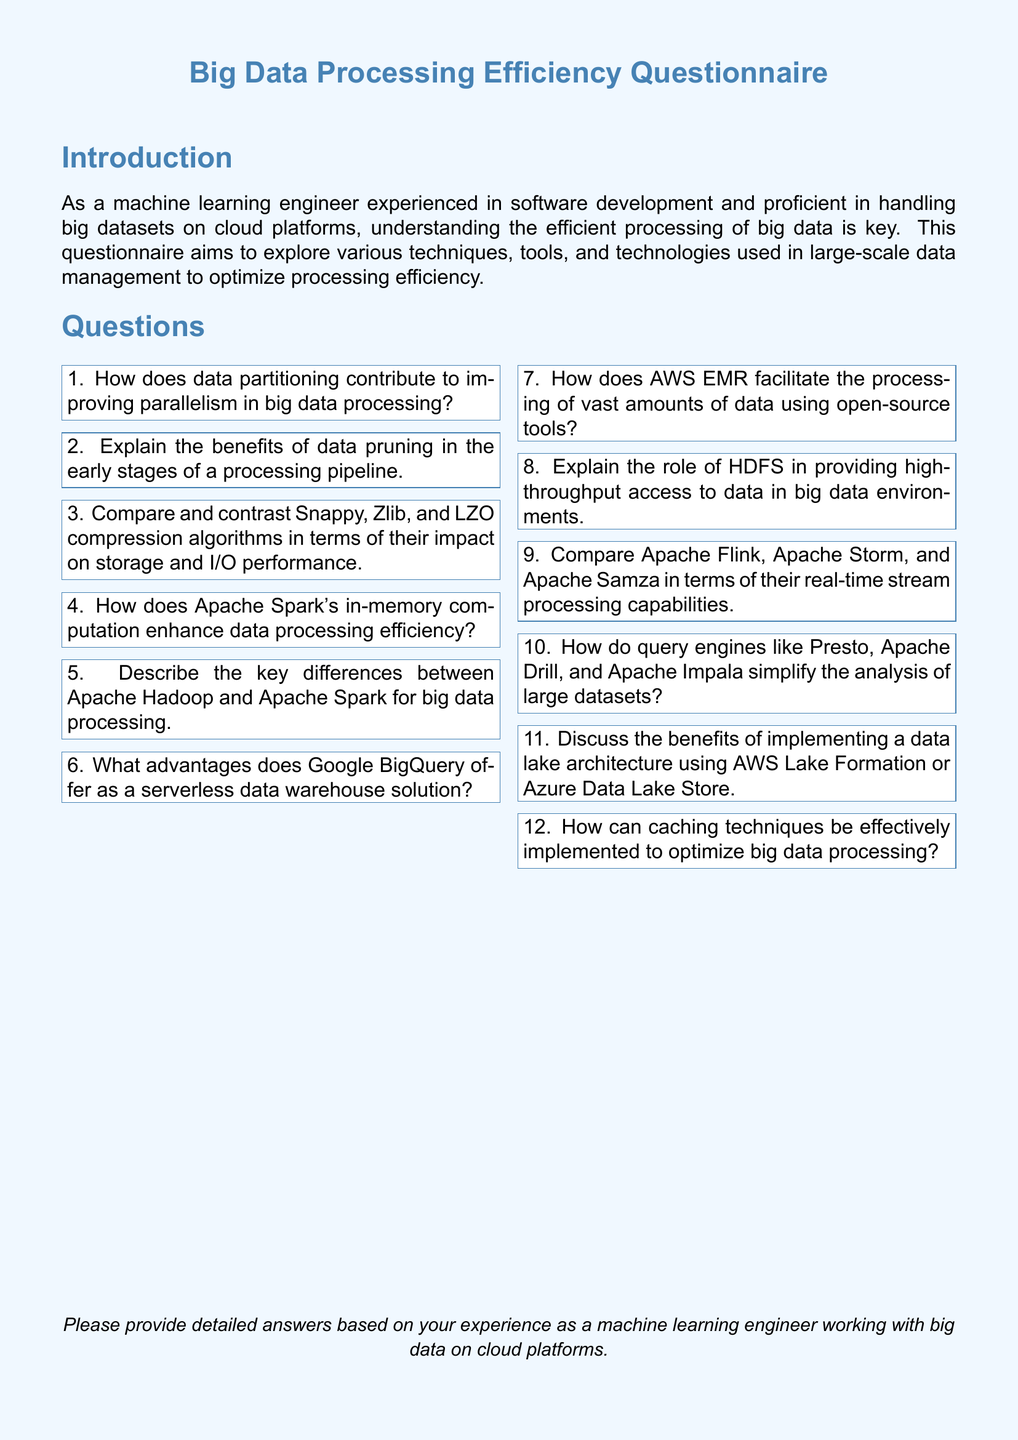What is the title of the document? The title prominently displayed at the top of the document is "Big Data Processing Efficiency Questionnaire."
Answer: Big Data Processing Efficiency Questionnaire How many sections are in the document? The document has two main sections: Introduction and Questions.
Answer: 2 What is the color of the header defined in the document? The color defined for the header in the document is RGB(70, 130, 180).
Answer: RGB(70, 130, 180) What is the purpose of the questionnaire? The purpose is to explore various techniques, tools, and technologies used in large-scale data management to optimize processing efficiency.
Answer: Optimize processing efficiency Which tool is specifically mentioned as facilitating data processing on AWS? The tool mentioned is AWS EMR, which facilitates data processing using open-source tools.
Answer: AWS EMR How many questions are included in the questionnaire? There are a total of twelve questions provided in the questionnaire.
Answer: 12 What is the suggested response format for the answers in the document? Respondents are encouraged to provide detailed answers based on their experience as a machine learning engineer working with big data on cloud platforms.
Answer: Detailed answers based on experience Which Apache project focuses on in-memory computation? The Apache project that focuses on in-memory computation is Apache Spark.
Answer: Apache Spark 